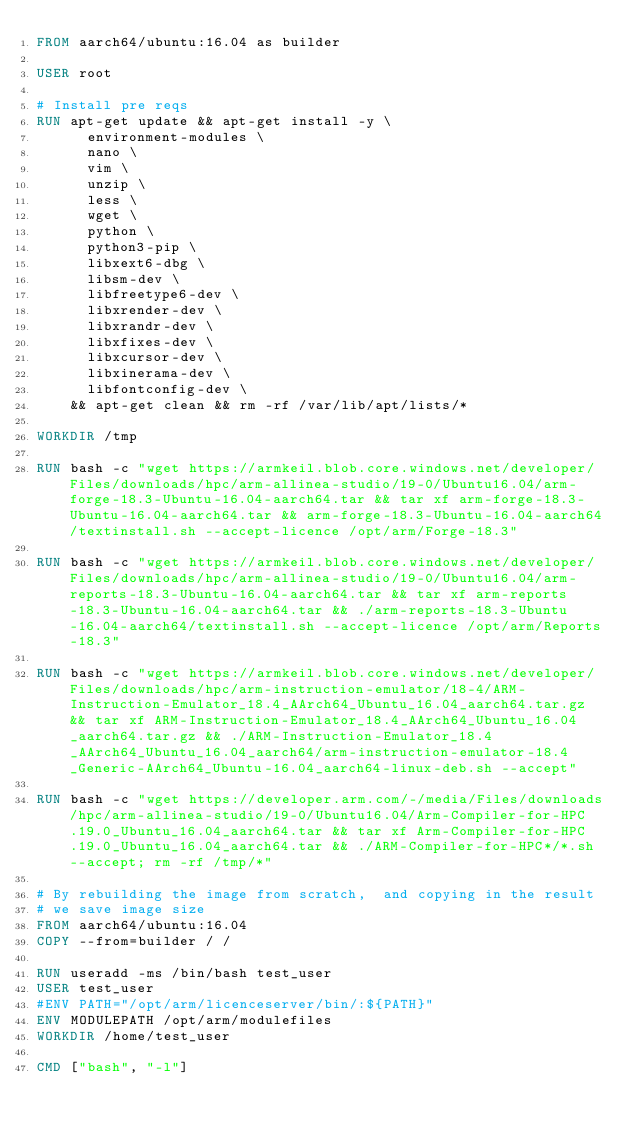Convert code to text. <code><loc_0><loc_0><loc_500><loc_500><_Dockerfile_>FROM aarch64/ubuntu:16.04 as builder

USER root

# Install pre reqs
RUN apt-get update && apt-get install -y \
      environment-modules \
      nano \
      vim \
      unzip \
      less \
      wget \
      python \
      python3-pip \
      libxext6-dbg \
      libsm-dev \
      libfreetype6-dev \
      libxrender-dev \
      libxrandr-dev \
      libxfixes-dev \
      libxcursor-dev \
      libxinerama-dev \
      libfontconfig-dev \
    && apt-get clean && rm -rf /var/lib/apt/lists/*

WORKDIR /tmp

RUN bash -c "wget https://armkeil.blob.core.windows.net/developer/Files/downloads/hpc/arm-allinea-studio/19-0/Ubuntu16.04/arm-forge-18.3-Ubuntu-16.04-aarch64.tar && tar xf arm-forge-18.3-Ubuntu-16.04-aarch64.tar && arm-forge-18.3-Ubuntu-16.04-aarch64/textinstall.sh --accept-licence /opt/arm/Forge-18.3"

RUN bash -c "wget https://armkeil.blob.core.windows.net/developer/Files/downloads/hpc/arm-allinea-studio/19-0/Ubuntu16.04/arm-reports-18.3-Ubuntu-16.04-aarch64.tar && tar xf arm-reports-18.3-Ubuntu-16.04-aarch64.tar && ./arm-reports-18.3-Ubuntu-16.04-aarch64/textinstall.sh --accept-licence /opt/arm/Reports-18.3"

RUN bash -c "wget https://armkeil.blob.core.windows.net/developer/Files/downloads/hpc/arm-instruction-emulator/18-4/ARM-Instruction-Emulator_18.4_AArch64_Ubuntu_16.04_aarch64.tar.gz && tar xf ARM-Instruction-Emulator_18.4_AArch64_Ubuntu_16.04_aarch64.tar.gz && ./ARM-Instruction-Emulator_18.4_AArch64_Ubuntu_16.04_aarch64/arm-instruction-emulator-18.4_Generic-AArch64_Ubuntu-16.04_aarch64-linux-deb.sh --accept"

RUN bash -c "wget https://developer.arm.com/-/media/Files/downloads/hpc/arm-allinea-studio/19-0/Ubuntu16.04/Arm-Compiler-for-HPC.19.0_Ubuntu_16.04_aarch64.tar && tar xf Arm-Compiler-for-HPC.19.0_Ubuntu_16.04_aarch64.tar && ./ARM-Compiler-for-HPC*/*.sh --accept; rm -rf /tmp/*"

# By rebuilding the image from scratch,  and copying in the result
# we save image size
FROM aarch64/ubuntu:16.04
COPY --from=builder / /

RUN useradd -ms /bin/bash test_user
USER test_user
#ENV PATH="/opt/arm/licenceserver/bin/:${PATH}"
ENV MODULEPATH /opt/arm/modulefiles
WORKDIR /home/test_user

CMD ["bash", "-l"]

</code> 